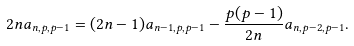Convert formula to latex. <formula><loc_0><loc_0><loc_500><loc_500>2 n a _ { n , p , p - 1 } = ( 2 n - 1 ) a _ { n - 1 , p , p - 1 } - \frac { p ( p - 1 ) } { 2 n } a _ { n , p - 2 , p - 1 } .</formula> 